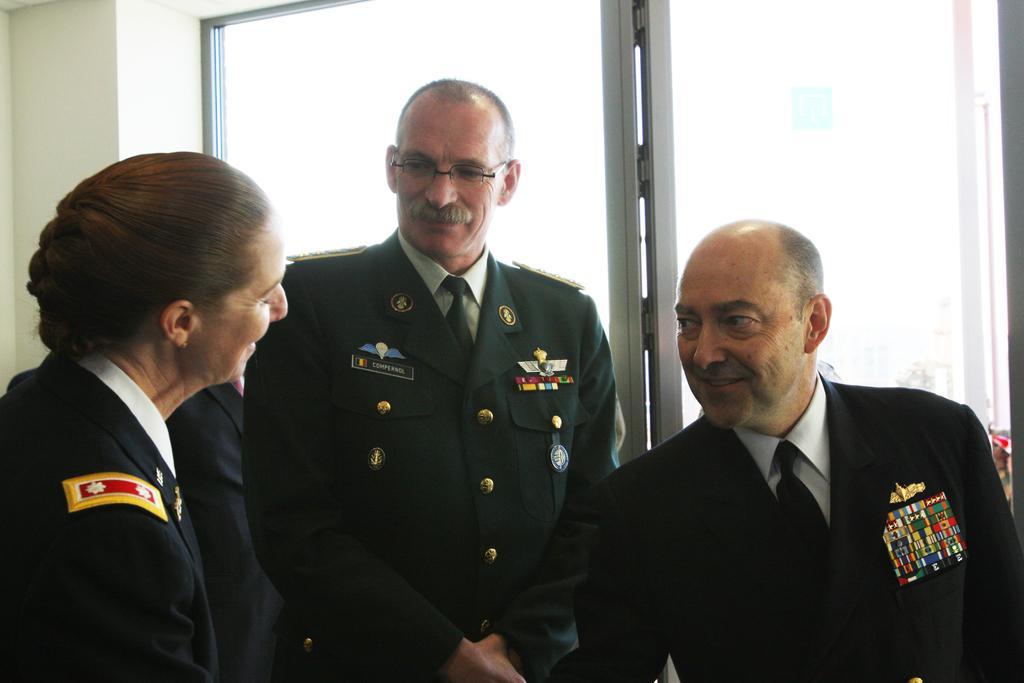Describe this image in one or two sentences. In the picture we can see a woman and two men are standing near the glass window and smiling, they are in uniforms. 